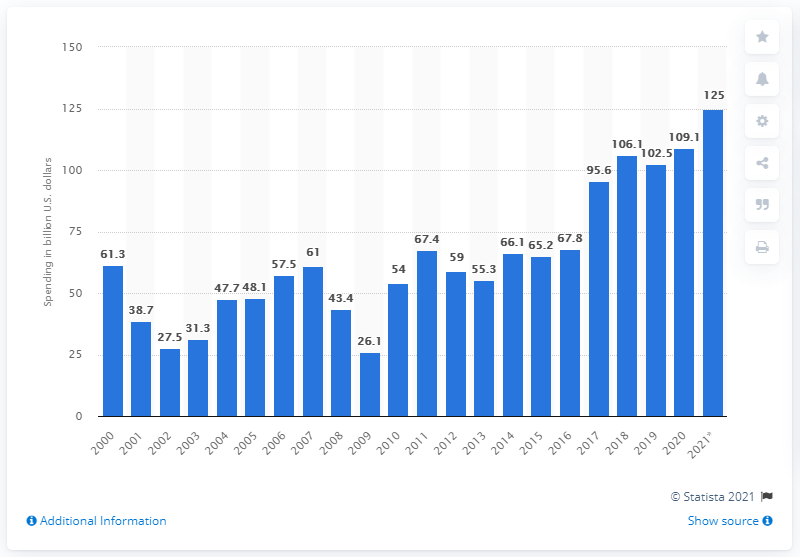Specify some key components in this picture. In 2020, global semiconductor capital spending reached 109.1. The projected amount of semiconductor capital spending in 2021 is expected to be approximately 125. 